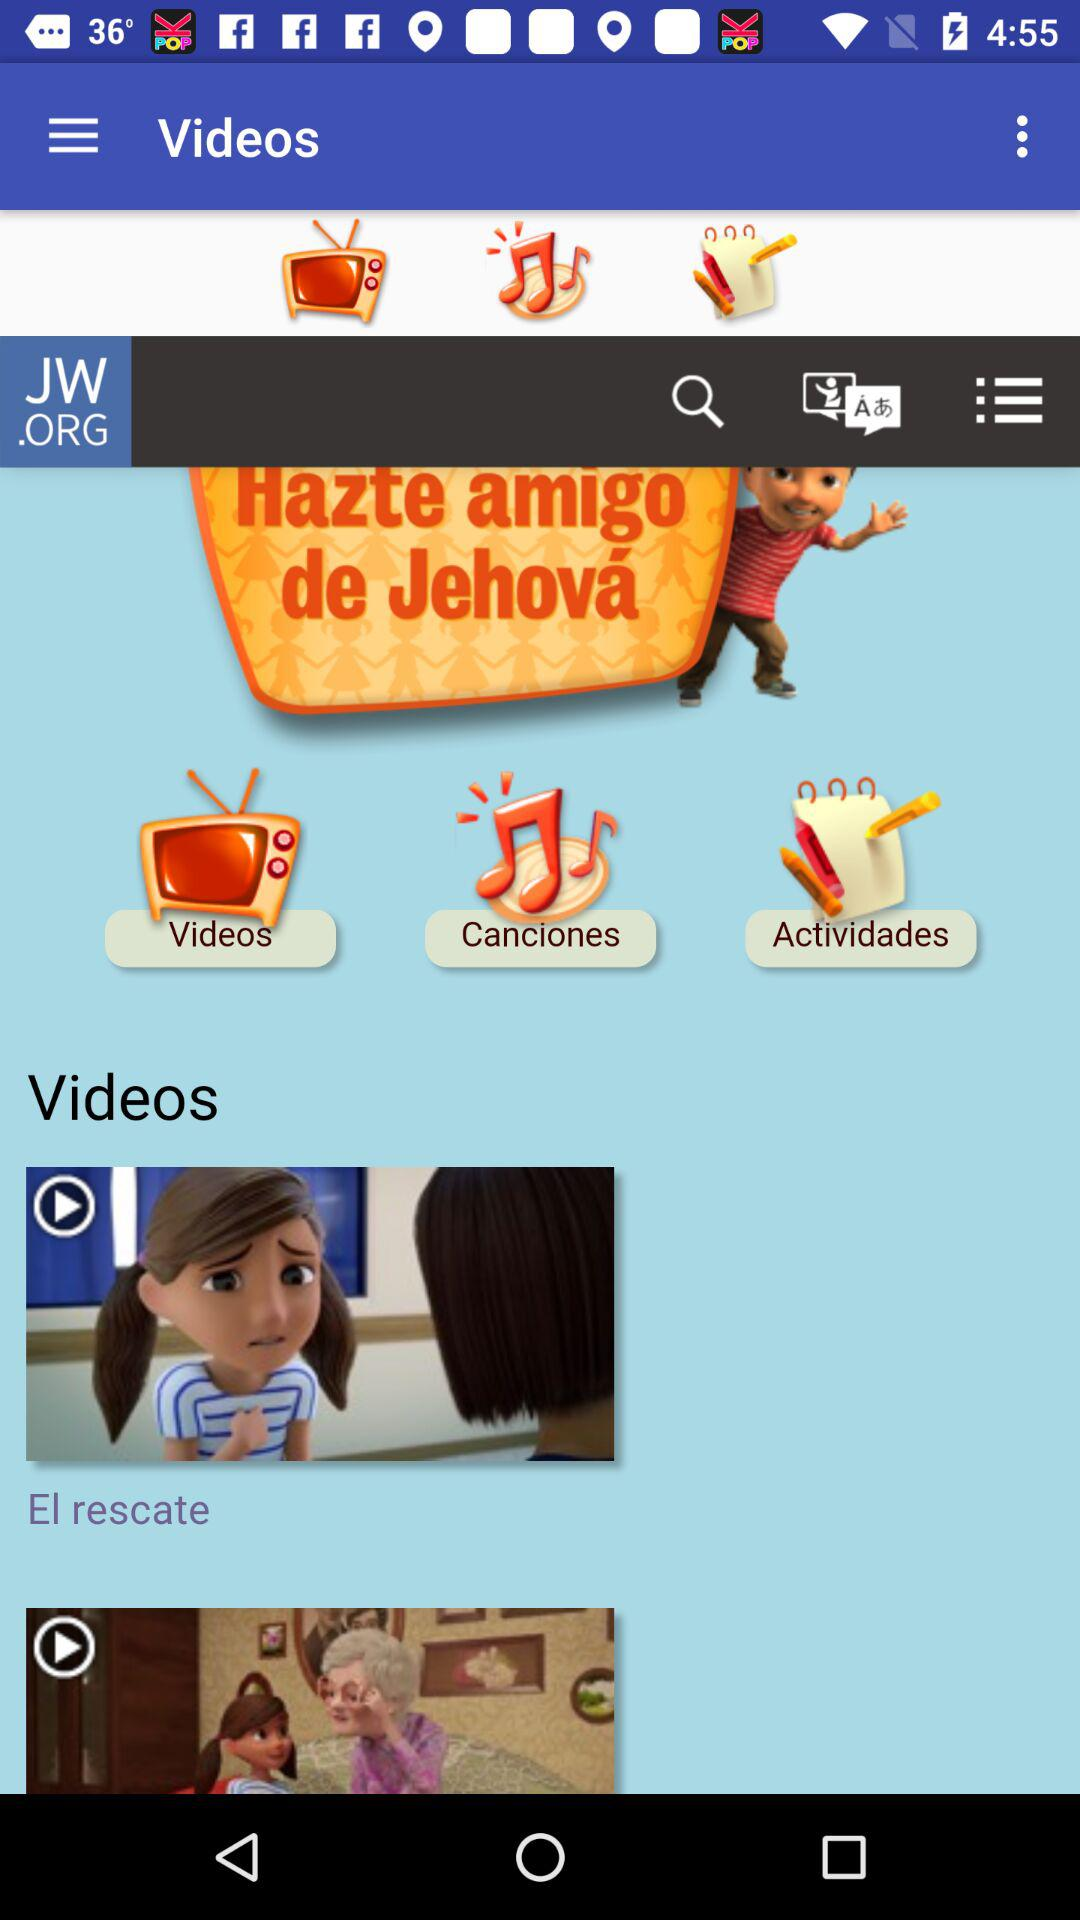How many more videos are there than activities?
Answer the question using a single word or phrase. 2 